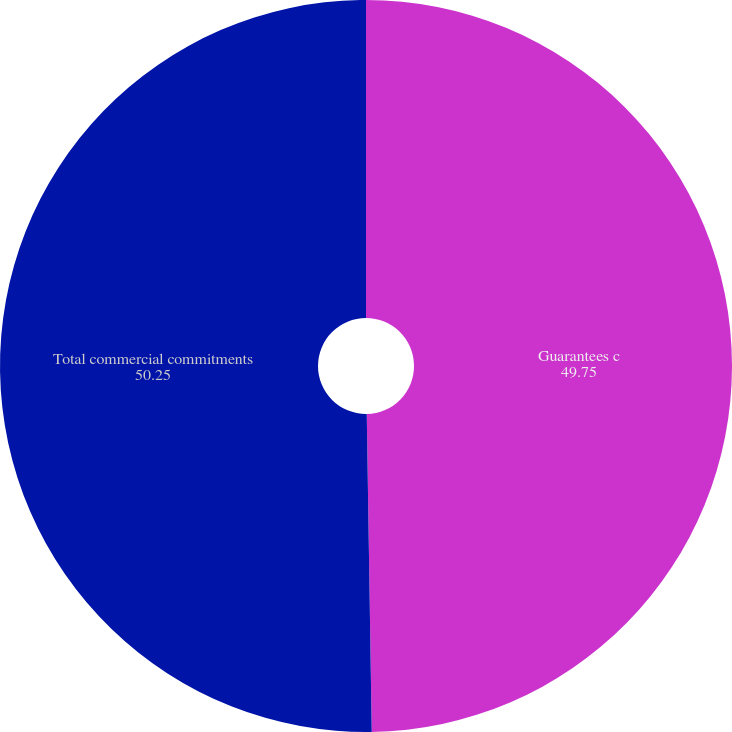<chart> <loc_0><loc_0><loc_500><loc_500><pie_chart><fcel>Guarantees c<fcel>Total commercial commitments<nl><fcel>49.75%<fcel>50.25%<nl></chart> 